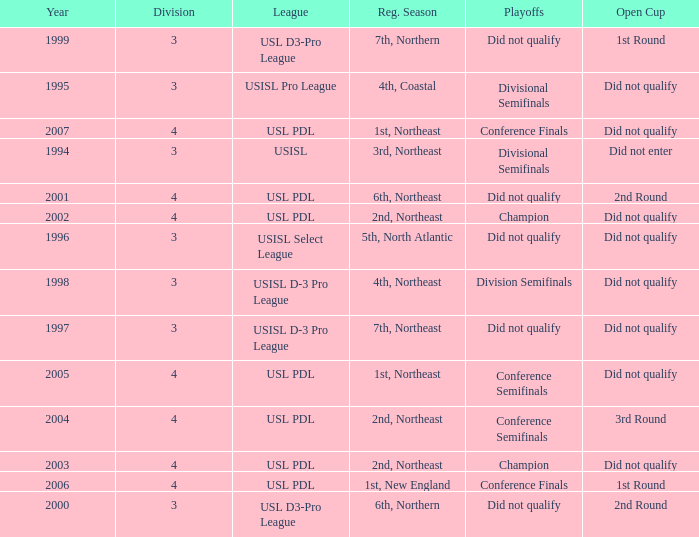Name the number of playoffs for 3rd round 1.0. Parse the full table. {'header': ['Year', 'Division', 'League', 'Reg. Season', 'Playoffs', 'Open Cup'], 'rows': [['1999', '3', 'USL D3-Pro League', '7th, Northern', 'Did not qualify', '1st Round'], ['1995', '3', 'USISL Pro League', '4th, Coastal', 'Divisional Semifinals', 'Did not qualify'], ['2007', '4', 'USL PDL', '1st, Northeast', 'Conference Finals', 'Did not qualify'], ['1994', '3', 'USISL', '3rd, Northeast', 'Divisional Semifinals', 'Did not enter'], ['2001', '4', 'USL PDL', '6th, Northeast', 'Did not qualify', '2nd Round'], ['2002', '4', 'USL PDL', '2nd, Northeast', 'Champion', 'Did not qualify'], ['1996', '3', 'USISL Select League', '5th, North Atlantic', 'Did not qualify', 'Did not qualify'], ['1998', '3', 'USISL D-3 Pro League', '4th, Northeast', 'Division Semifinals', 'Did not qualify'], ['1997', '3', 'USISL D-3 Pro League', '7th, Northeast', 'Did not qualify', 'Did not qualify'], ['2005', '4', 'USL PDL', '1st, Northeast', 'Conference Semifinals', 'Did not qualify'], ['2004', '4', 'USL PDL', '2nd, Northeast', 'Conference Semifinals', '3rd Round'], ['2003', '4', 'USL PDL', '2nd, Northeast', 'Champion', 'Did not qualify'], ['2006', '4', 'USL PDL', '1st, New England', 'Conference Finals', '1st Round'], ['2000', '3', 'USL D3-Pro League', '6th, Northern', 'Did not qualify', '2nd Round']]} 